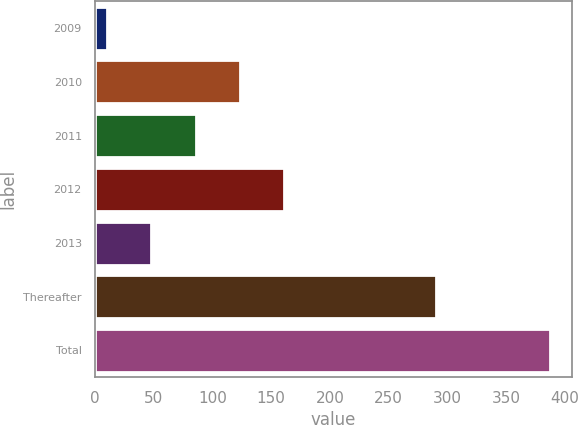Convert chart. <chart><loc_0><loc_0><loc_500><loc_500><bar_chart><fcel>2009<fcel>2010<fcel>2011<fcel>2012<fcel>2013<fcel>Thereafter<fcel>Total<nl><fcel>10.3<fcel>123.34<fcel>85.66<fcel>161.02<fcel>47.98<fcel>290.2<fcel>387.1<nl></chart> 